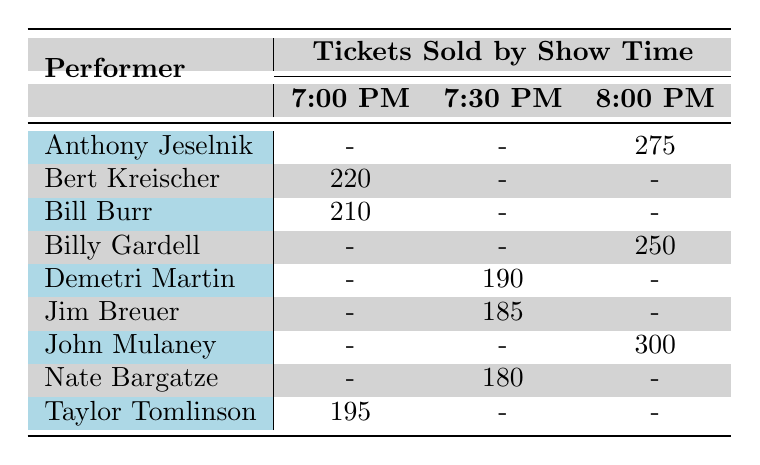What performer had the highest ticket sales at 8:00 PM? Looking at the 8:00 PM showtime, John Mulaney is the only performer listed with ticket sales of 300. No other performers sold tickets during that time.
Answer: John Mulaney How many tickets were sold by Taylor Tomlinson at 7:00 PM? Referring to the table, Taylor Tomlinson sold 195 tickets during the 7:00 PM show.
Answer: 195 Did Jim Breuer sell more tickets at 7:30 PM than Nate Bargatze? Jim Breuer sold 185 tickets at 7:30 PM, while Nate Bargatze sold 180 tickets at that time. Since 185 is greater than 180, the answer is yes.
Answer: Yes What was the total number of tickets sold during all the 7:00 PM shows? Adding the ticket sales for all performances at 7:00 PM: Bill Burr (210) + Taylor Tomlinson (195) + Bert Kreischer (220) = 625 tickets total.
Answer: 625 Is there any performer who sold tickets at both 7:00 PM and 9:30 PM? By examining the table, it shows that performers only sold tickets during one of the two times listed as there are no overlaps in the 7:00 PM and 9:30 PM categories.
Answer: No Which venue had the most tickets sold in the 8:00 PM time slot? The only performer listed for the 8:00 PM slot is John Mulaney, who performed at Byham Theater with 300 tickets sold. There are no other competitors in this time slot for comparison, so Byham Theater is the answer.
Answer: Byham Theater How many more tickets did Bert Kreischer sell at 7:00 PM than Jim Breuer at 7:30 PM? Bert Kreischer sold 220 tickets at 7:00 PM while Jim Breuer sold 185 tickets at 7:30 PM. The difference can be calculated: 220 - 185 = 35 tickets.
Answer: 35 Which performer sold tickets at the most popular showtime (i.e., highest sold tickets per time)? Analyzing all showtimes, John Mulaney generated the highest sales with 300 tickets sold at 8:00 PM. Therefore, he performed at the most popular showtime in terms of ticket sales.
Answer: John Mulaney 